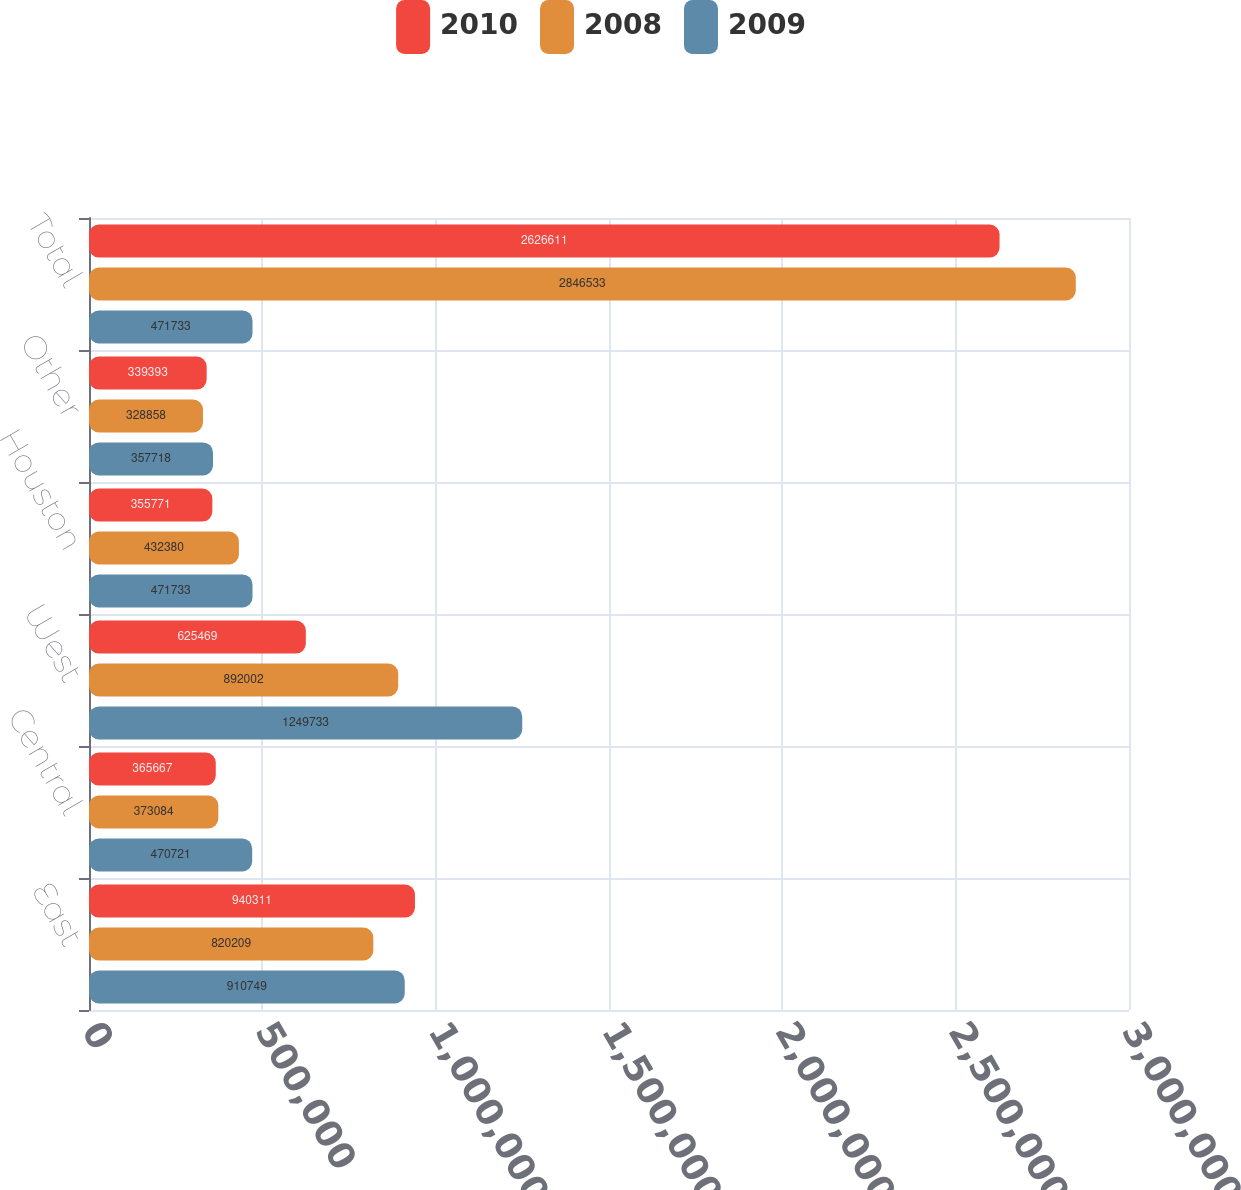Convert chart to OTSL. <chart><loc_0><loc_0><loc_500><loc_500><stacked_bar_chart><ecel><fcel>East<fcel>Central<fcel>West<fcel>Houston<fcel>Other<fcel>Total<nl><fcel>2010<fcel>940311<fcel>365667<fcel>625469<fcel>355771<fcel>339393<fcel>2.62661e+06<nl><fcel>2008<fcel>820209<fcel>373084<fcel>892002<fcel>432380<fcel>328858<fcel>2.84653e+06<nl><fcel>2009<fcel>910749<fcel>470721<fcel>1.24973e+06<fcel>471733<fcel>357718<fcel>471733<nl></chart> 